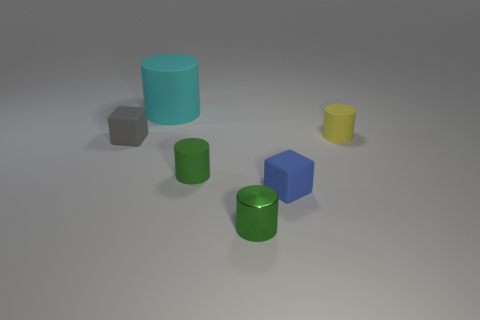Subtract 1 cylinders. How many cylinders are left? 3 Add 1 rubber blocks. How many objects exist? 7 Subtract all cylinders. How many objects are left? 2 Add 2 gray rubber cubes. How many gray rubber cubes are left? 3 Add 5 tiny cubes. How many tiny cubes exist? 7 Subtract 0 cyan blocks. How many objects are left? 6 Subtract all tiny green metallic cylinders. Subtract all small matte things. How many objects are left? 1 